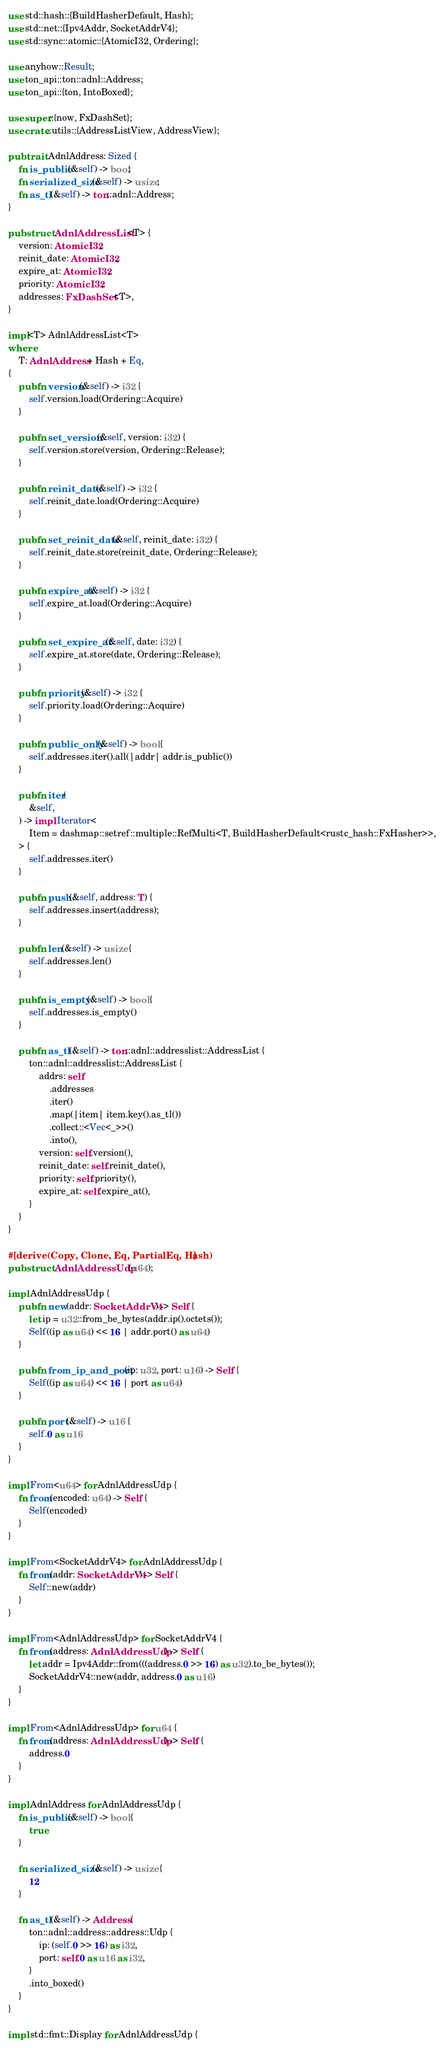<code> <loc_0><loc_0><loc_500><loc_500><_Rust_>use std::hash::{BuildHasherDefault, Hash};
use std::net::{Ipv4Addr, SocketAddrV4};
use std::sync::atomic::{AtomicI32, Ordering};

use anyhow::Result;
use ton_api::ton::adnl::Address;
use ton_api::{ton, IntoBoxed};

use super::{now, FxDashSet};
use crate::utils::{AddressListView, AddressView};

pub trait AdnlAddress: Sized {
    fn is_public(&self) -> bool;
    fn serialized_size(&self) -> usize;
    fn as_tl(&self) -> ton::adnl::Address;
}

pub struct AdnlAddressList<T> {
    version: AtomicI32,
    reinit_date: AtomicI32,
    expire_at: AtomicI32,
    priority: AtomicI32,
    addresses: FxDashSet<T>,
}

impl<T> AdnlAddressList<T>
where
    T: AdnlAddress + Hash + Eq,
{
    pub fn version(&self) -> i32 {
        self.version.load(Ordering::Acquire)
    }

    pub fn set_version(&self, version: i32) {
        self.version.store(version, Ordering::Release);
    }

    pub fn reinit_date(&self) -> i32 {
        self.reinit_date.load(Ordering::Acquire)
    }

    pub fn set_reinit_date(&self, reinit_date: i32) {
        self.reinit_date.store(reinit_date, Ordering::Release);
    }

    pub fn expire_at(&self) -> i32 {
        self.expire_at.load(Ordering::Acquire)
    }

    pub fn set_expire_at(&self, date: i32) {
        self.expire_at.store(date, Ordering::Release);
    }

    pub fn priority(&self) -> i32 {
        self.priority.load(Ordering::Acquire)
    }

    pub fn public_only(&self) -> bool {
        self.addresses.iter().all(|addr| addr.is_public())
    }

    pub fn iter(
        &self,
    ) -> impl Iterator<
        Item = dashmap::setref::multiple::RefMulti<T, BuildHasherDefault<rustc_hash::FxHasher>>,
    > {
        self.addresses.iter()
    }

    pub fn push(&self, address: T) {
        self.addresses.insert(address);
    }

    pub fn len(&self) -> usize {
        self.addresses.len()
    }

    pub fn is_empty(&self) -> bool {
        self.addresses.is_empty()
    }

    pub fn as_tl(&self) -> ton::adnl::addresslist::AddressList {
        ton::adnl::addresslist::AddressList {
            addrs: self
                .addresses
                .iter()
                .map(|item| item.key().as_tl())
                .collect::<Vec<_>>()
                .into(),
            version: self.version(),
            reinit_date: self.reinit_date(),
            priority: self.priority(),
            expire_at: self.expire_at(),
        }
    }
}

#[derive(Copy, Clone, Eq, PartialEq, Hash)]
pub struct AdnlAddressUdp(u64);

impl AdnlAddressUdp {
    pub fn new(addr: SocketAddrV4) -> Self {
        let ip = u32::from_be_bytes(addr.ip().octets());
        Self((ip as u64) << 16 | addr.port() as u64)
    }

    pub fn from_ip_and_port(ip: u32, port: u16) -> Self {
        Self((ip as u64) << 16 | port as u64)
    }

    pub fn port(&self) -> u16 {
        self.0 as u16
    }
}

impl From<u64> for AdnlAddressUdp {
    fn from(encoded: u64) -> Self {
        Self(encoded)
    }
}

impl From<SocketAddrV4> for AdnlAddressUdp {
    fn from(addr: SocketAddrV4) -> Self {
        Self::new(addr)
    }
}

impl From<AdnlAddressUdp> for SocketAddrV4 {
    fn from(address: AdnlAddressUdp) -> Self {
        let addr = Ipv4Addr::from(((address.0 >> 16) as u32).to_be_bytes());
        SocketAddrV4::new(addr, address.0 as u16)
    }
}

impl From<AdnlAddressUdp> for u64 {
    fn from(address: AdnlAddressUdp) -> Self {
        address.0
    }
}

impl AdnlAddress for AdnlAddressUdp {
    fn is_public(&self) -> bool {
        true
    }

    fn serialized_size(&self) -> usize {
        12
    }

    fn as_tl(&self) -> Address {
        ton::adnl::address::address::Udp {
            ip: (self.0 >> 16) as i32,
            port: self.0 as u16 as i32,
        }
        .into_boxed()
    }
}

impl std::fmt::Display for AdnlAddressUdp {</code> 